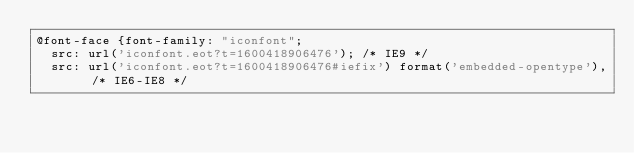<code> <loc_0><loc_0><loc_500><loc_500><_CSS_>@font-face {font-family: "iconfont";
  src: url('iconfont.eot?t=1600418906476'); /* IE9 */
  src: url('iconfont.eot?t=1600418906476#iefix') format('embedded-opentype'), /* IE6-IE8 */</code> 